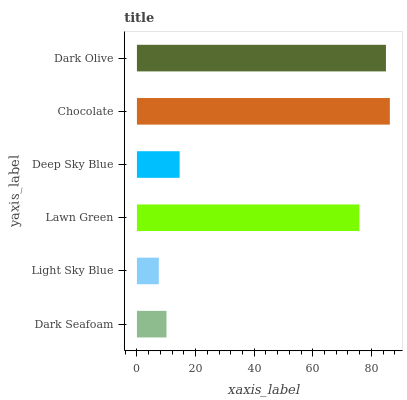Is Light Sky Blue the minimum?
Answer yes or no. Yes. Is Chocolate the maximum?
Answer yes or no. Yes. Is Lawn Green the minimum?
Answer yes or no. No. Is Lawn Green the maximum?
Answer yes or no. No. Is Lawn Green greater than Light Sky Blue?
Answer yes or no. Yes. Is Light Sky Blue less than Lawn Green?
Answer yes or no. Yes. Is Light Sky Blue greater than Lawn Green?
Answer yes or no. No. Is Lawn Green less than Light Sky Blue?
Answer yes or no. No. Is Lawn Green the high median?
Answer yes or no. Yes. Is Deep Sky Blue the low median?
Answer yes or no. Yes. Is Light Sky Blue the high median?
Answer yes or no. No. Is Dark Olive the low median?
Answer yes or no. No. 